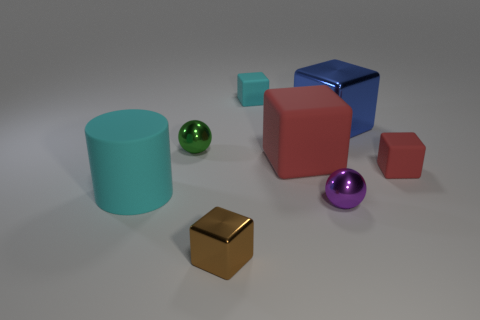Subtract all brown cubes. How many cubes are left? 4 Subtract all small red blocks. How many blocks are left? 4 Subtract 2 cubes. How many cubes are left? 3 Subtract all gray cubes. Subtract all red cylinders. How many cubes are left? 5 Add 1 balls. How many objects exist? 9 Subtract all balls. How many objects are left? 6 Subtract 0 gray cylinders. How many objects are left? 8 Subtract all yellow rubber cubes. Subtract all cyan cubes. How many objects are left? 7 Add 3 small green balls. How many small green balls are left? 4 Add 4 small green metallic things. How many small green metallic things exist? 5 